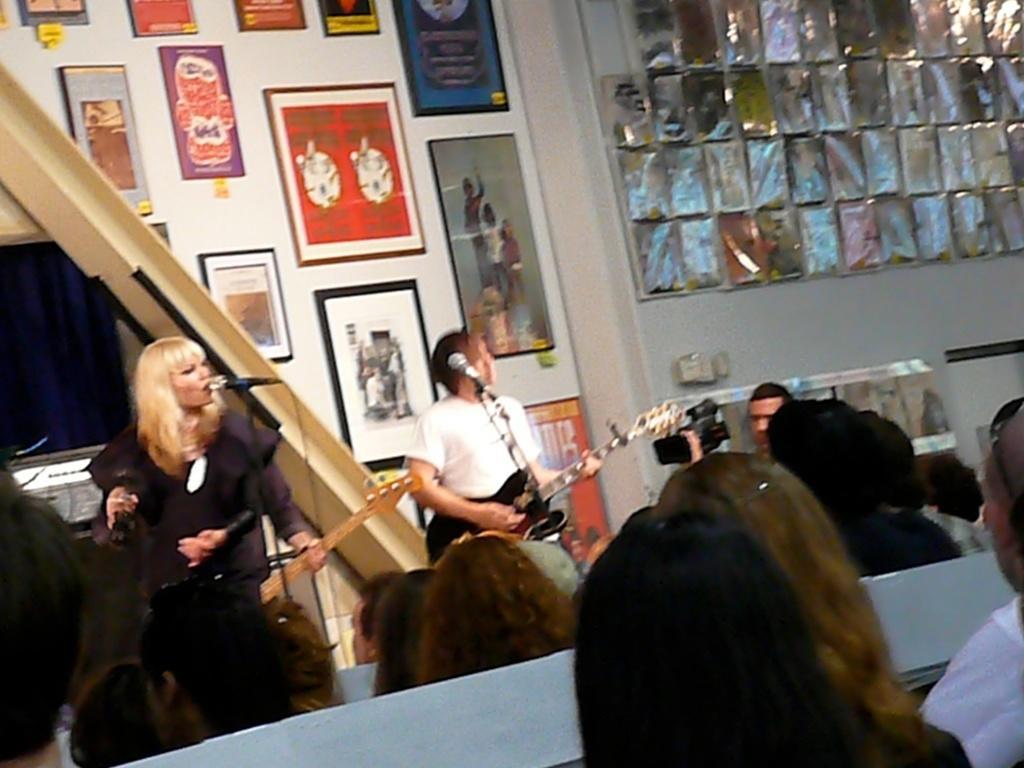How would you summarize this image in a sentence or two? In this picture I can see group of people sitting, there are three persons standing, there are miles with the miles stands,two persons holding guitars, a person holding a camera, and in the background there are frames attached to the wall and there are some other objects. 